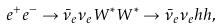Convert formula to latex. <formula><loc_0><loc_0><loc_500><loc_500>e ^ { + } e ^ { - } \rightarrow \bar { \nu } _ { e } \nu _ { e } W ^ { * } W ^ { * } \rightarrow \bar { \nu } _ { e } \nu _ { e } h h ,</formula> 